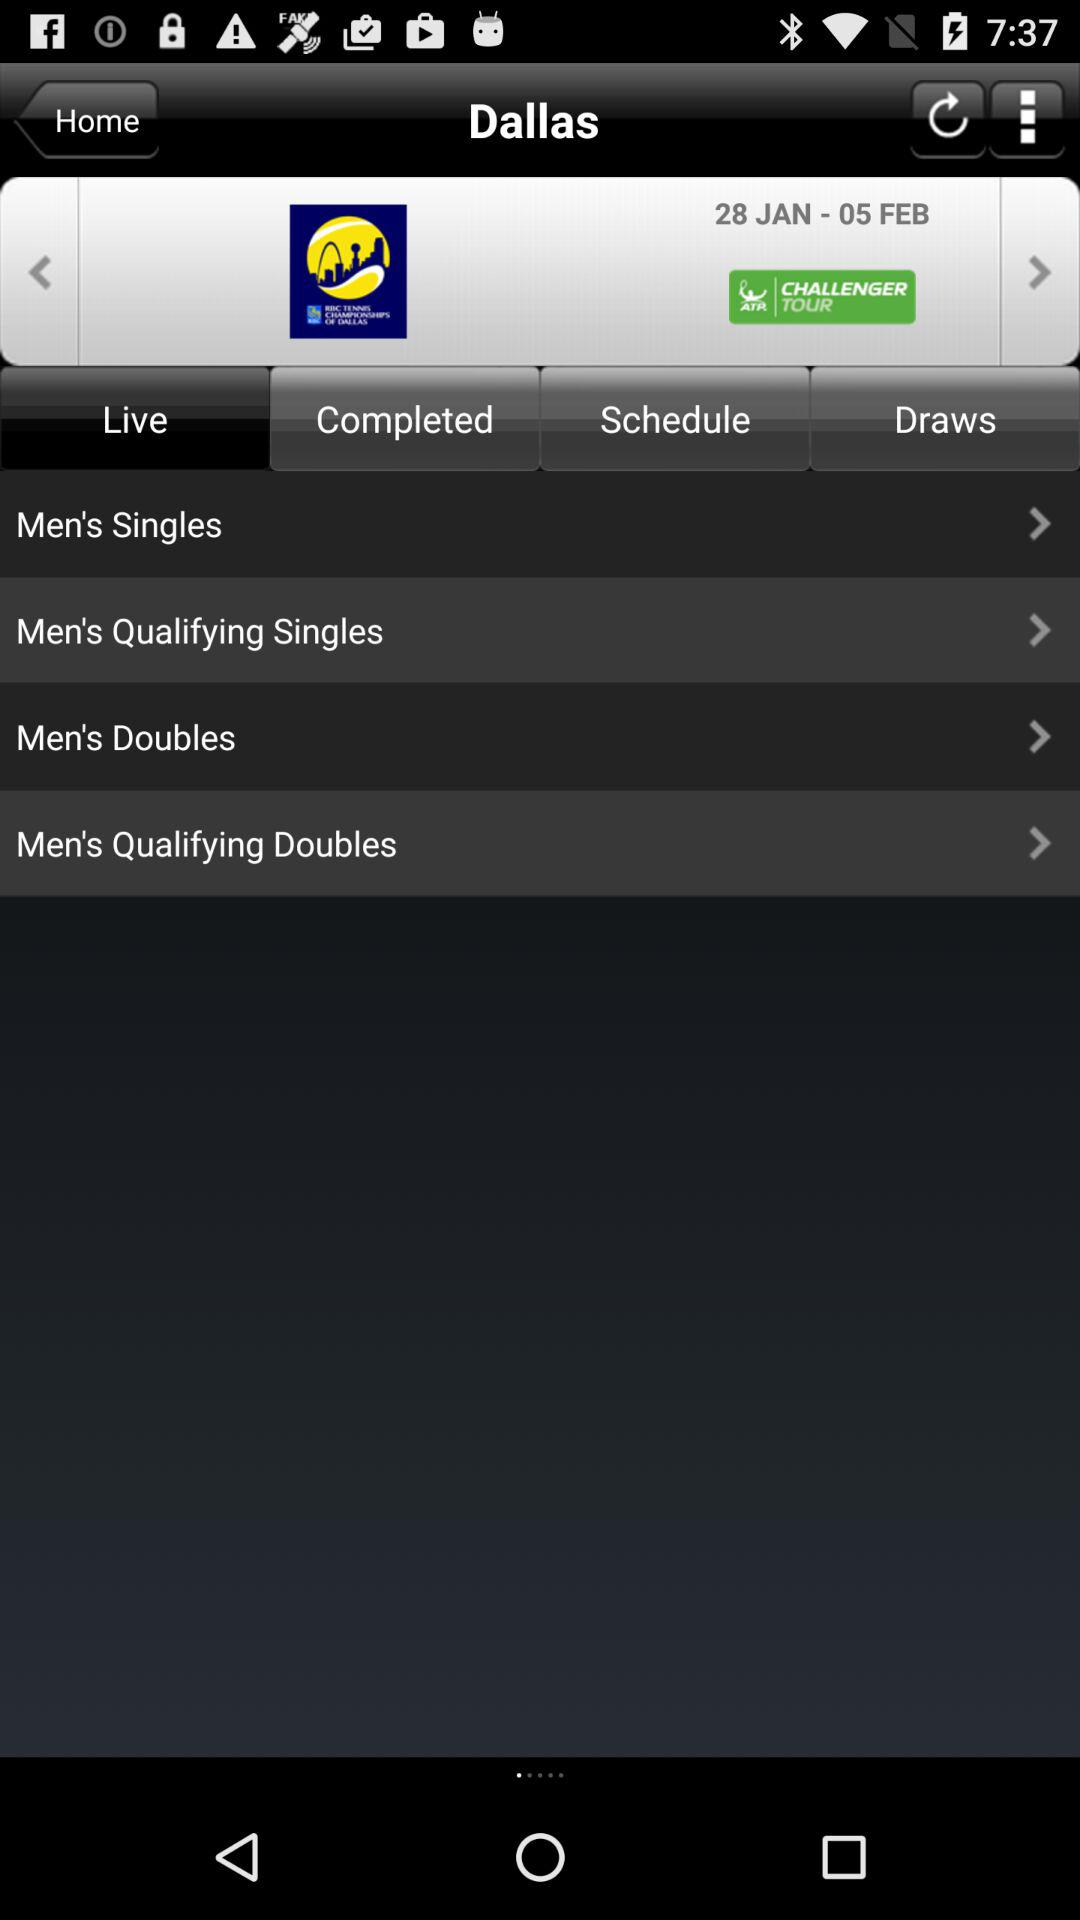From which date is the match data given? The date from which match data is given is January 28. 